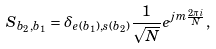Convert formula to latex. <formula><loc_0><loc_0><loc_500><loc_500>S _ { b _ { 2 } , b _ { 1 } } = \delta _ { e ( b _ { 1 } ) , s ( b _ { 2 } ) } \frac { 1 } { \sqrt { N } } e ^ { j m \frac { 2 \pi i } N } ,</formula> 